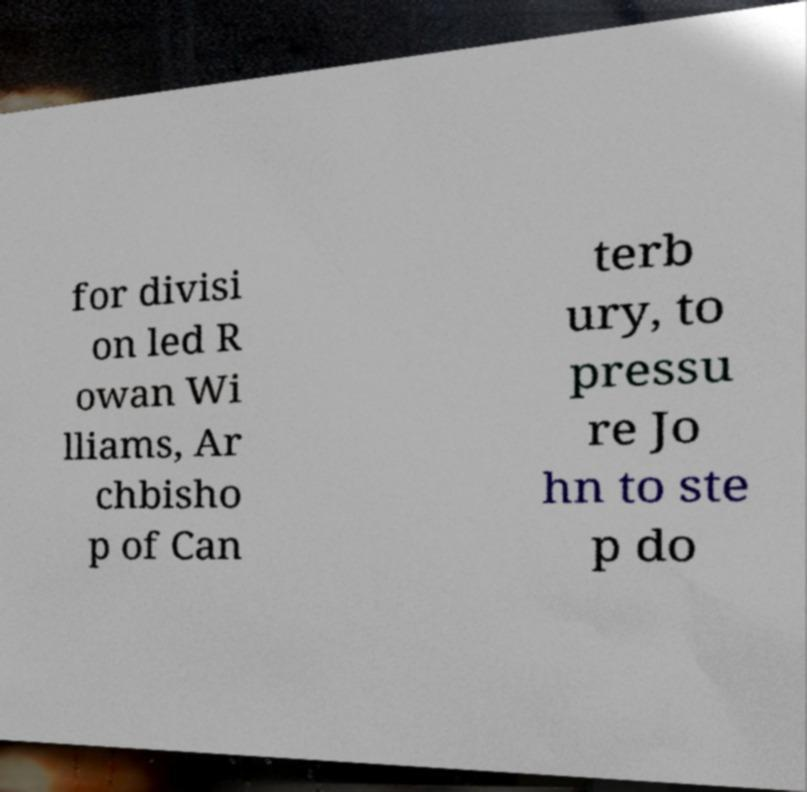Can you accurately transcribe the text from the provided image for me? for divisi on led R owan Wi lliams, Ar chbisho p of Can terb ury, to pressu re Jo hn to ste p do 